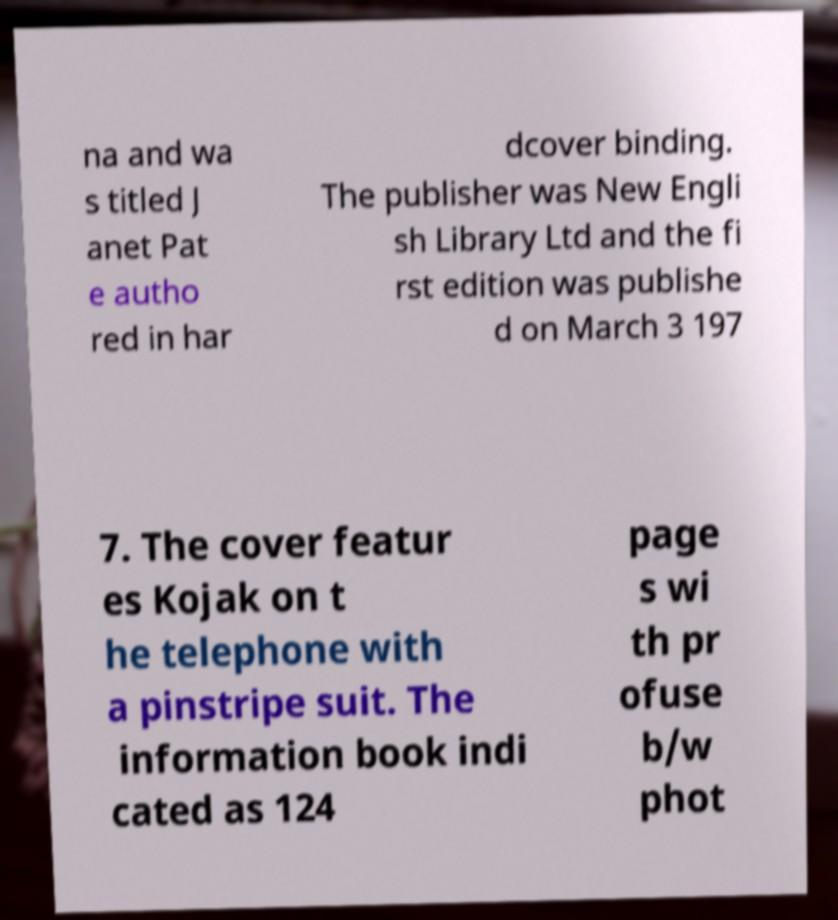What messages or text are displayed in this image? I need them in a readable, typed format. na and wa s titled J anet Pat e autho red in har dcover binding. The publisher was New Engli sh Library Ltd and the fi rst edition was publishe d on March 3 197 7. The cover featur es Kojak on t he telephone with a pinstripe suit. The information book indi cated as 124 page s wi th pr ofuse b/w phot 